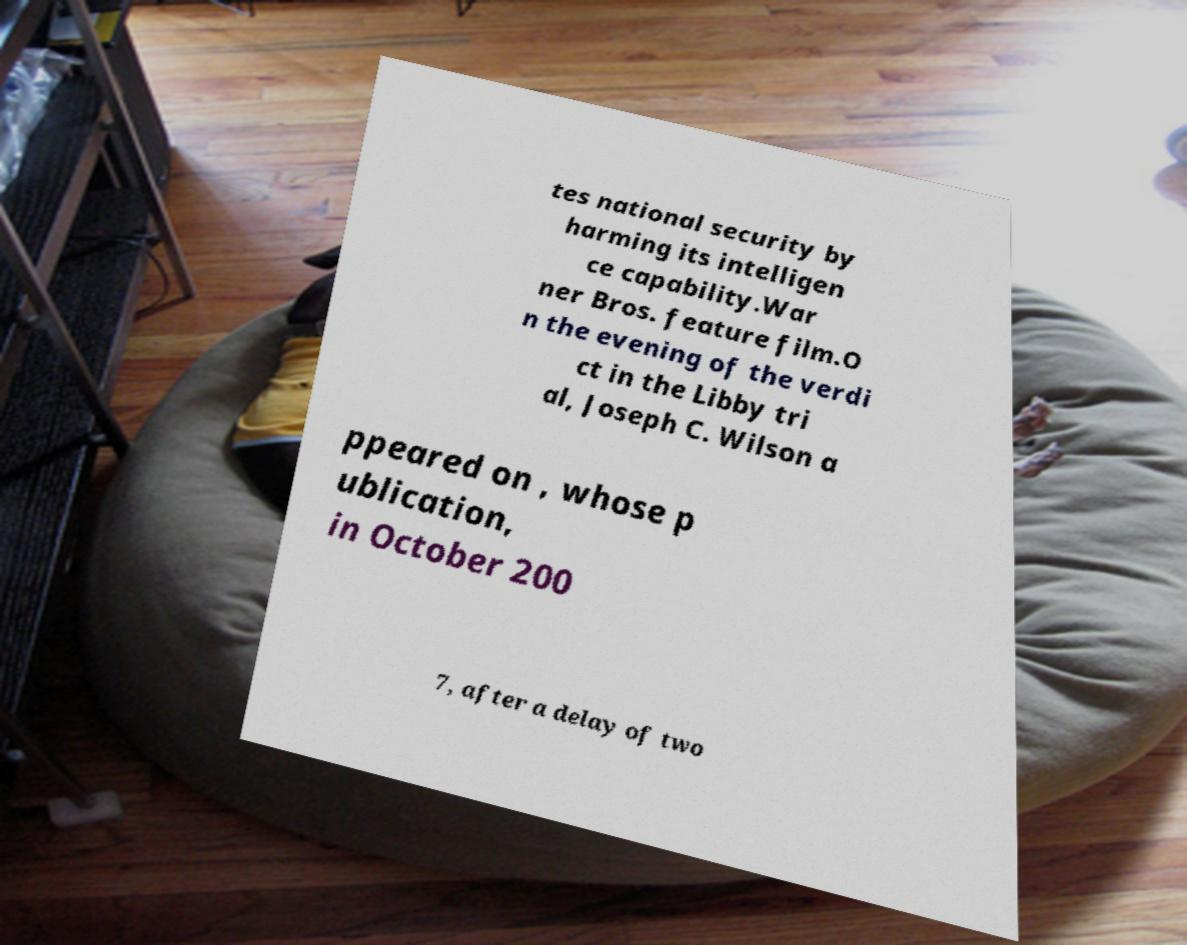Could you extract and type out the text from this image? tes national security by harming its intelligen ce capability.War ner Bros. feature film.O n the evening of the verdi ct in the Libby tri al, Joseph C. Wilson a ppeared on , whose p ublication, in October 200 7, after a delay of two 